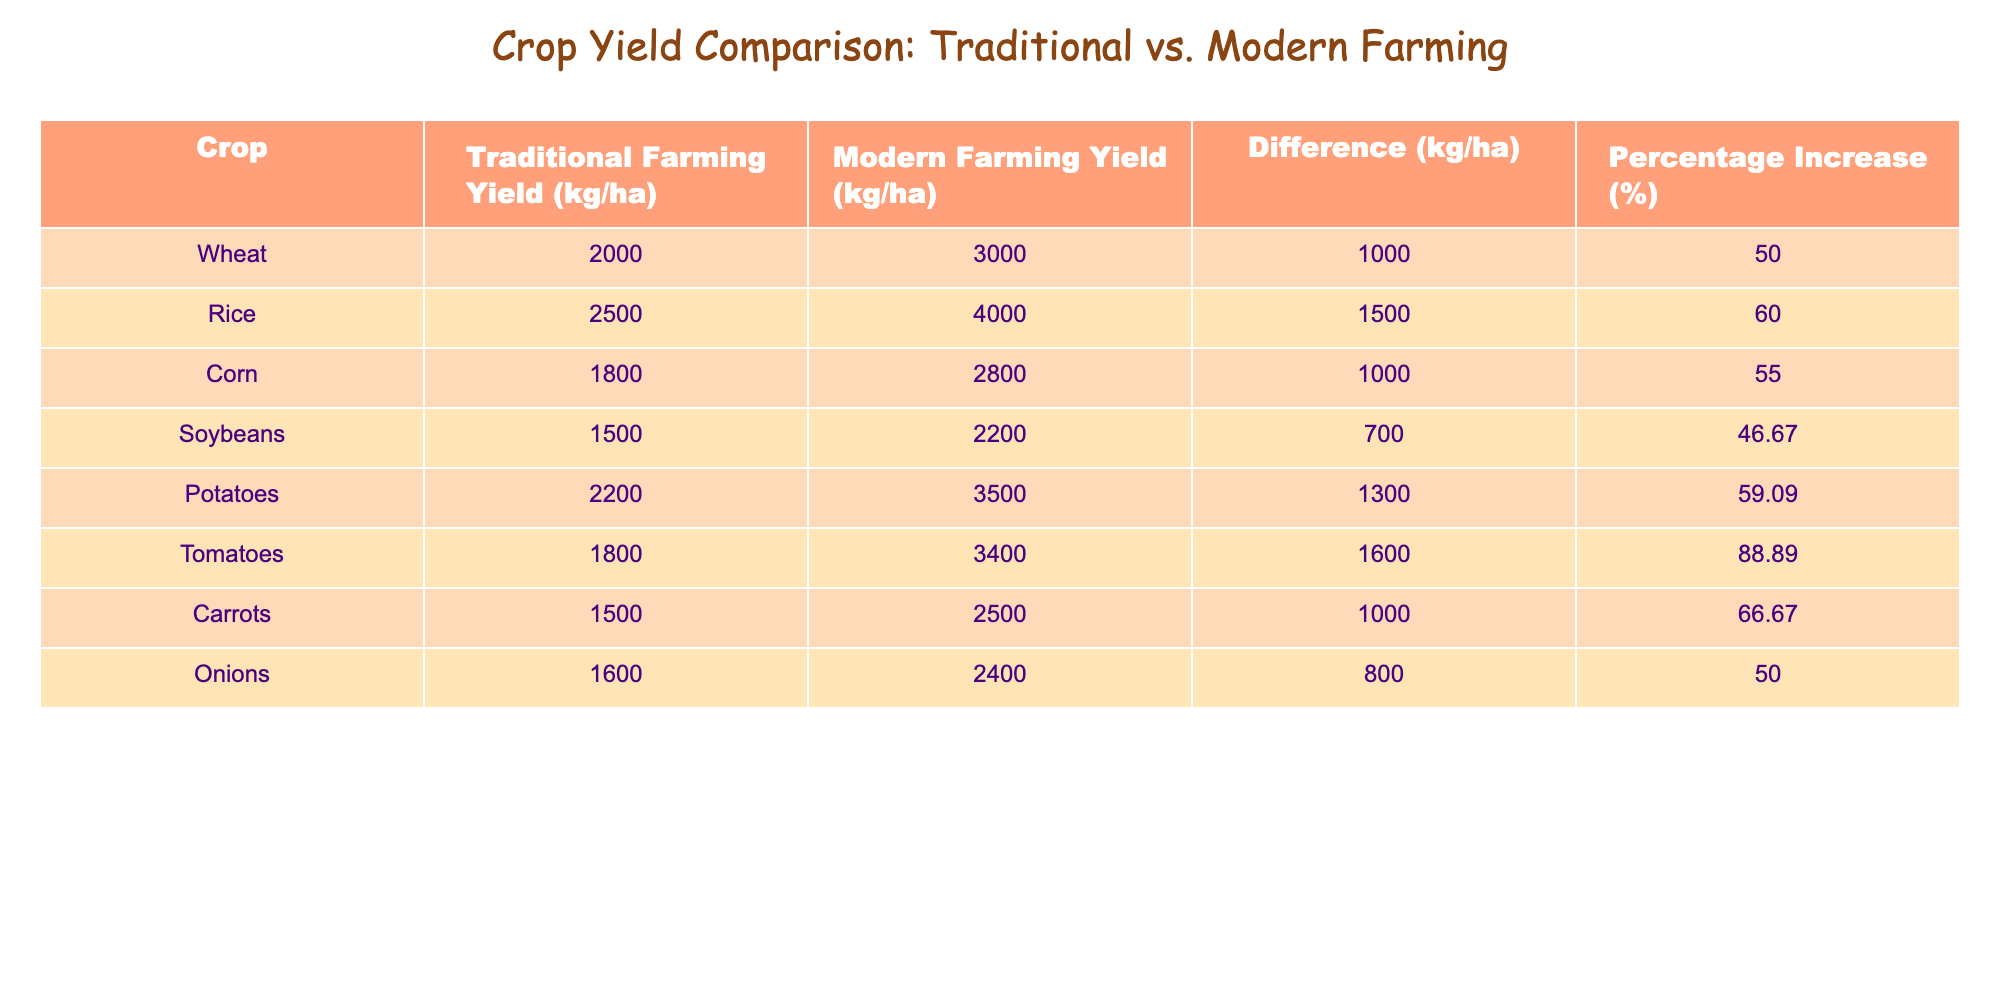What is the highest yield obtained using modern farming techniques? By scanning the table, I look for the maximum value in the "Modern Farming Yield" column. The highest value is 4000 kg/ha for Rice.
Answer: 4000 kg/ha What is the yield difference for Potatoes between traditional and modern farming techniques? I locate the row for Potatoes in the table. The yield difference is given in the "Difference" column, which shows 1300 kg/ha.
Answer: 1300 kg/ha Is the percentage increase in yield for Corn greater than that of Soybeans? To answer this, I need to check the "Percentage Increase" column for both Corn and Soybeans. Corn has a percentage increase of 55%, while Soybeans has 46.67%, which means Corn's increase is indeed higher.
Answer: Yes What is the average yield difference across all crops listed in the table? I first sum the differences from the "Difference" column: 1000 + 1500 + 1000 + 700 + 1300 + 1600 + 1000 + 800 = 6100 kg/ha. There are 8 crops, so I divide 6100 by 8, resulting in an average difference of 762.5 kg/ha.
Answer: 762.5 kg/ha Which crop shows the least percentage increase in yield after adopting modern farming techniques? I review the "Percentage Increase" column to find the smallest value. The least percentage increase is for Soybeans, at 46.67%.
Answer: Soybeans Does the yield of traditional farming outperform the yield of modern farming for any of the listed crops? I compare the "Traditional Farming Yield" and "Modern Farming Yield" columns for each crop. In all cases, modern farming yields are higher than traditional farming, thus the answer is no.
Answer: No What is the total yield of traditional farming techniques for all crops combined? I sum the values in the "Traditional Farming Yield" column: 2000 + 2500 + 1800 + 1500 + 2200 + 1800 + 1500 + 1600 = 13900 kg/ha.
Answer: 13900 kg/ha Which crop has the second highest yield using traditional farming techniques? After listing the traditional yields in order, I find the crop with the second-highest yield. The highest is Wheat at 2000 kg/ha, followed by Rice at 2500 kg/ha.
Answer: Rice 